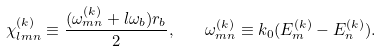Convert formula to latex. <formula><loc_0><loc_0><loc_500><loc_500>\chi _ { l m n } ^ { ( k ) } \equiv \frac { ( \omega _ { m n } ^ { ( k ) } + l \omega _ { b } ) r _ { b } } { 2 } , \quad \omega _ { m n } ^ { ( k ) } \equiv k _ { 0 } ( E _ { m } ^ { ( k ) } - E _ { n } ^ { ( k ) } ) .</formula> 